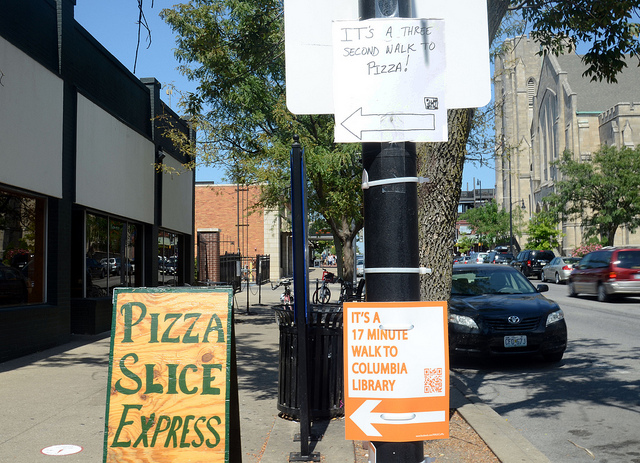Are there any environmental or community-based messages conveyed by the signs in the image? Yes, the signage promotes walkability and awareness of local destinations, such as the indication of a '17 minute walk to Columbia Library.' This promotes environmental consciousness by encouraging walking instead of driving. Moreover, the practical information offered by the signs can foster a sense of community by connecting residents and visitors with local landmarks and amenities, supporting local businesses and public institutions like libraries. 